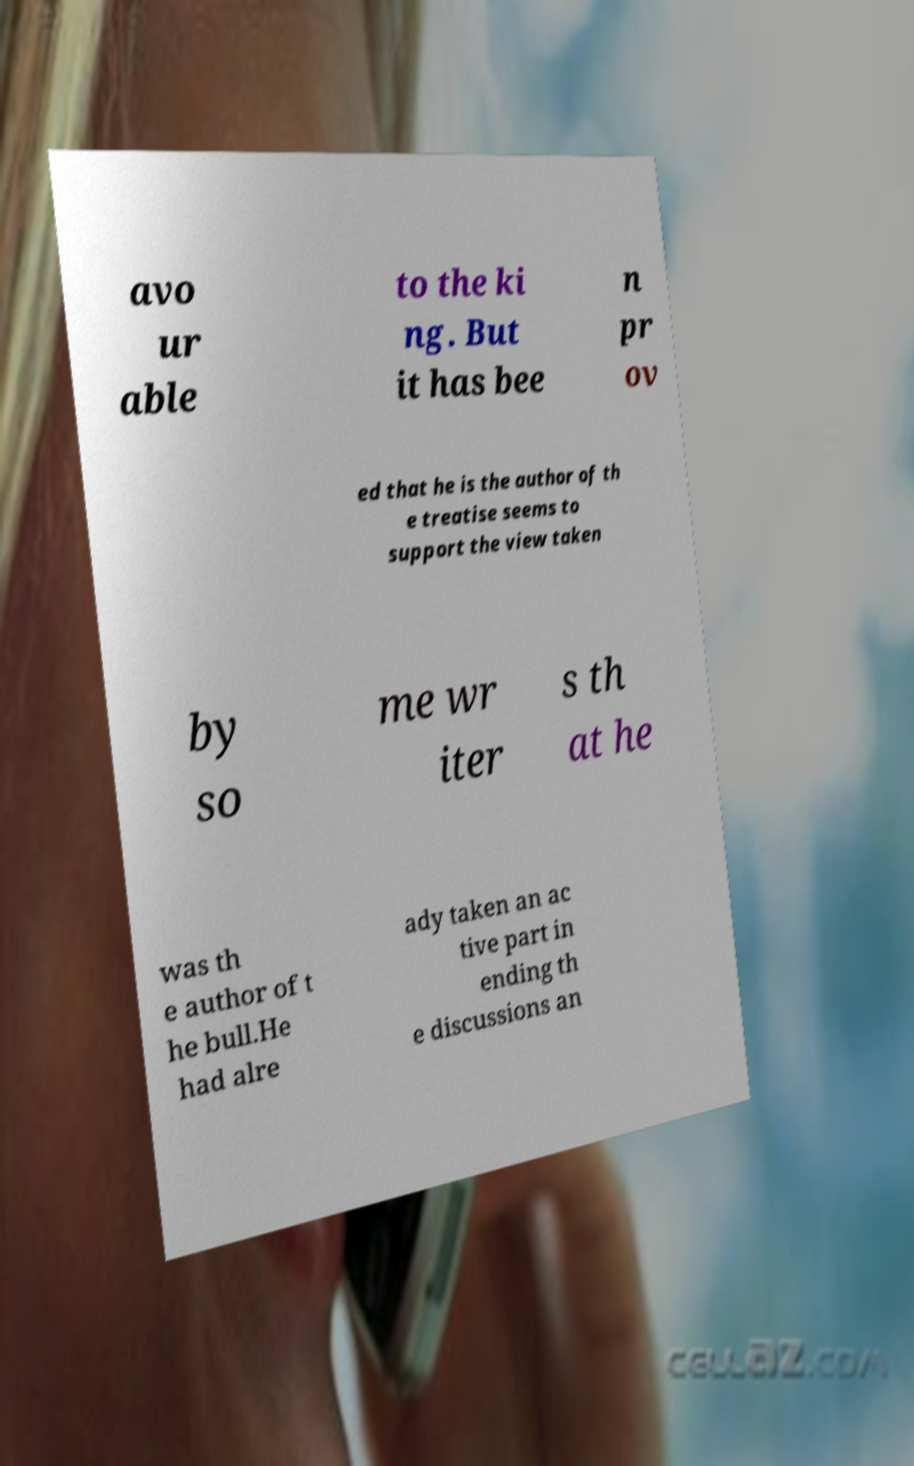Could you extract and type out the text from this image? avo ur able to the ki ng. But it has bee n pr ov ed that he is the author of th e treatise seems to support the view taken by so me wr iter s th at he was th e author of t he bull.He had alre ady taken an ac tive part in ending th e discussions an 